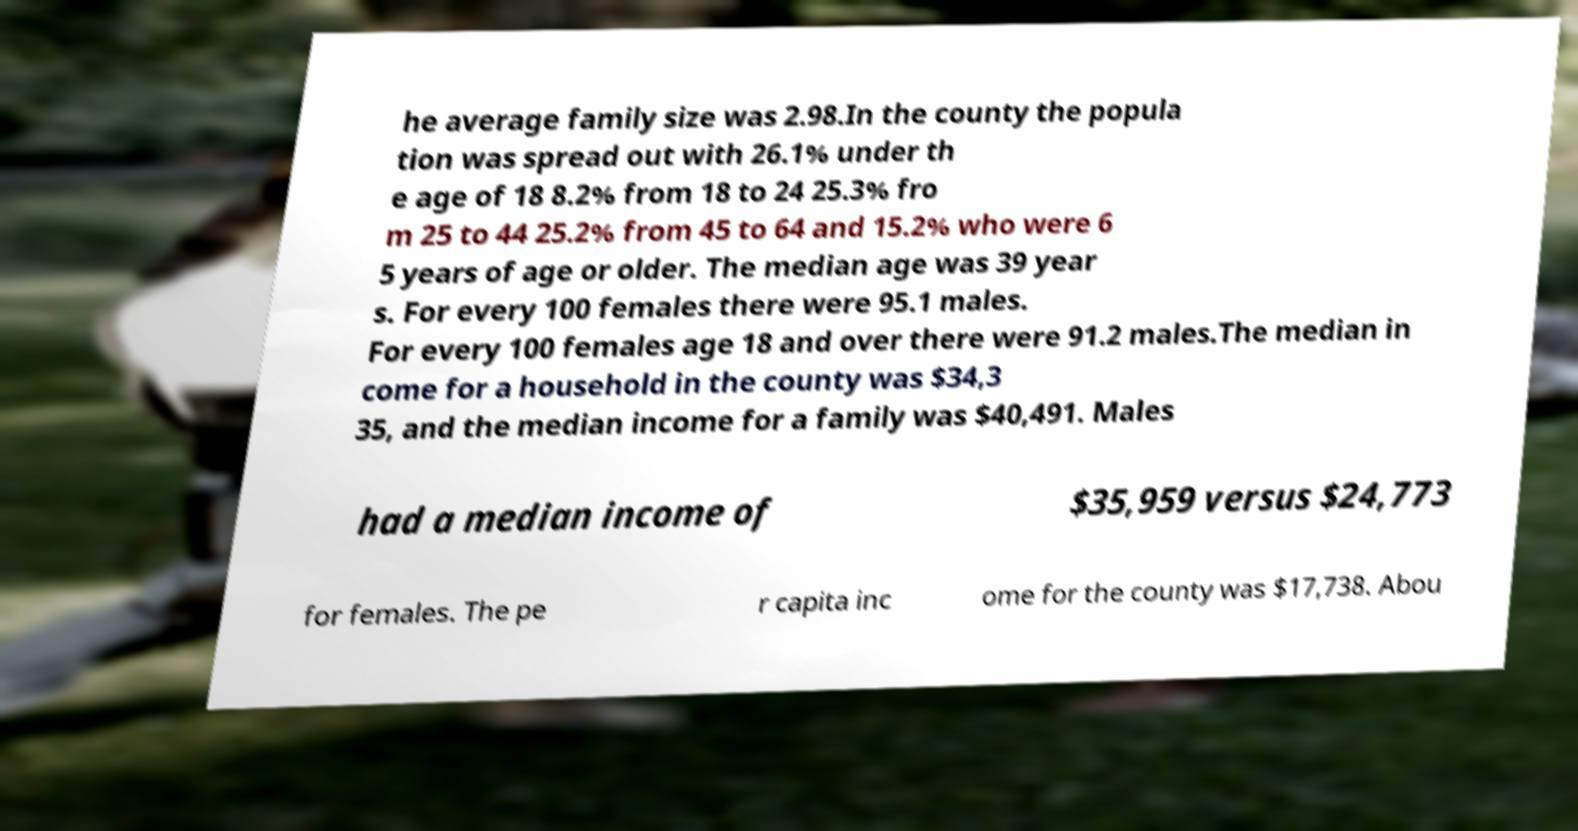For documentation purposes, I need the text within this image transcribed. Could you provide that? he average family size was 2.98.In the county the popula tion was spread out with 26.1% under th e age of 18 8.2% from 18 to 24 25.3% fro m 25 to 44 25.2% from 45 to 64 and 15.2% who were 6 5 years of age or older. The median age was 39 year s. For every 100 females there were 95.1 males. For every 100 females age 18 and over there were 91.2 males.The median in come for a household in the county was $34,3 35, and the median income for a family was $40,491. Males had a median income of $35,959 versus $24,773 for females. The pe r capita inc ome for the county was $17,738. Abou 